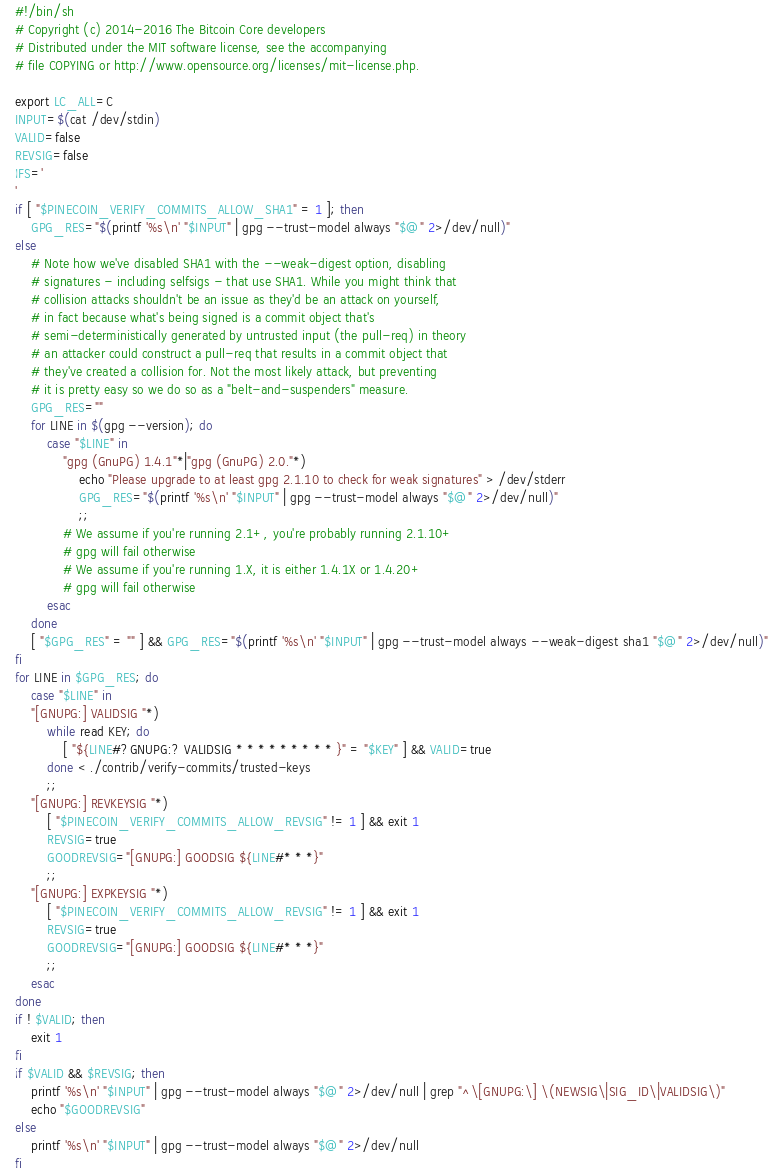<code> <loc_0><loc_0><loc_500><loc_500><_Bash_>#!/bin/sh
# Copyright (c) 2014-2016 The Bitcoin Core developers
# Distributed under the MIT software license, see the accompanying
# file COPYING or http://www.opensource.org/licenses/mit-license.php.

export LC_ALL=C
INPUT=$(cat /dev/stdin)
VALID=false
REVSIG=false
IFS='
'
if [ "$PINECOIN_VERIFY_COMMITS_ALLOW_SHA1" = 1 ]; then
	GPG_RES="$(printf '%s\n' "$INPUT" | gpg --trust-model always "$@" 2>/dev/null)"
else
	# Note how we've disabled SHA1 with the --weak-digest option, disabling
	# signatures - including selfsigs - that use SHA1. While you might think that
	# collision attacks shouldn't be an issue as they'd be an attack on yourself,
	# in fact because what's being signed is a commit object that's
	# semi-deterministically generated by untrusted input (the pull-req) in theory
	# an attacker could construct a pull-req that results in a commit object that
	# they've created a collision for. Not the most likely attack, but preventing
	# it is pretty easy so we do so as a "belt-and-suspenders" measure.
	GPG_RES=""
	for LINE in $(gpg --version); do
		case "$LINE" in
			"gpg (GnuPG) 1.4.1"*|"gpg (GnuPG) 2.0."*)
				echo "Please upgrade to at least gpg 2.1.10 to check for weak signatures" > /dev/stderr
				GPG_RES="$(printf '%s\n' "$INPUT" | gpg --trust-model always "$@" 2>/dev/null)"
				;;
			# We assume if you're running 2.1+, you're probably running 2.1.10+
			# gpg will fail otherwise
			# We assume if you're running 1.X, it is either 1.4.1X or 1.4.20+
			# gpg will fail otherwise
		esac
	done
	[ "$GPG_RES" = "" ] && GPG_RES="$(printf '%s\n' "$INPUT" | gpg --trust-model always --weak-digest sha1 "$@" 2>/dev/null)"
fi
for LINE in $GPG_RES; do
	case "$LINE" in
	"[GNUPG:] VALIDSIG "*)
		while read KEY; do
			[ "${LINE#?GNUPG:? VALIDSIG * * * * * * * * * }" = "$KEY" ] && VALID=true
		done < ./contrib/verify-commits/trusted-keys
		;;
	"[GNUPG:] REVKEYSIG "*)
		[ "$PINECOIN_VERIFY_COMMITS_ALLOW_REVSIG" != 1 ] && exit 1
		REVSIG=true
		GOODREVSIG="[GNUPG:] GOODSIG ${LINE#* * *}"
		;;
	"[GNUPG:] EXPKEYSIG "*)
		[ "$PINECOIN_VERIFY_COMMITS_ALLOW_REVSIG" != 1 ] && exit 1
		REVSIG=true
		GOODREVSIG="[GNUPG:] GOODSIG ${LINE#* * *}"
		;;
	esac
done
if ! $VALID; then
	exit 1
fi
if $VALID && $REVSIG; then
	printf '%s\n' "$INPUT" | gpg --trust-model always "$@" 2>/dev/null | grep "^\[GNUPG:\] \(NEWSIG\|SIG_ID\|VALIDSIG\)"
	echo "$GOODREVSIG"
else
	printf '%s\n' "$INPUT" | gpg --trust-model always "$@" 2>/dev/null
fi
</code> 